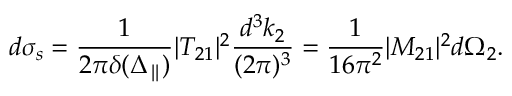Convert formula to latex. <formula><loc_0><loc_0><loc_500><loc_500>d \sigma _ { s } = \frac { 1 } { 2 \pi \delta ( \Delta _ { \| } ) } | T _ { 2 1 } | ^ { 2 } \frac { d ^ { 3 } k _ { 2 } } { ( 2 \pi ) ^ { 3 } } = \frac { 1 } { 1 6 \pi ^ { 2 } } | M _ { 2 1 } | ^ { 2 } d \Omega _ { 2 } .</formula> 